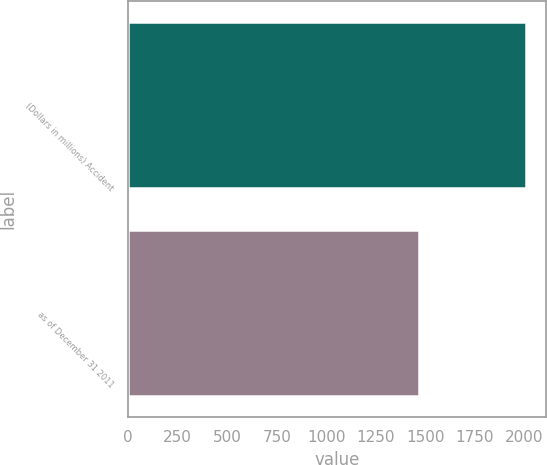<chart> <loc_0><loc_0><loc_500><loc_500><bar_chart><fcel>(Dollars in millions) Accident<fcel>as of December 31 2011<nl><fcel>2009<fcel>1467<nl></chart> 